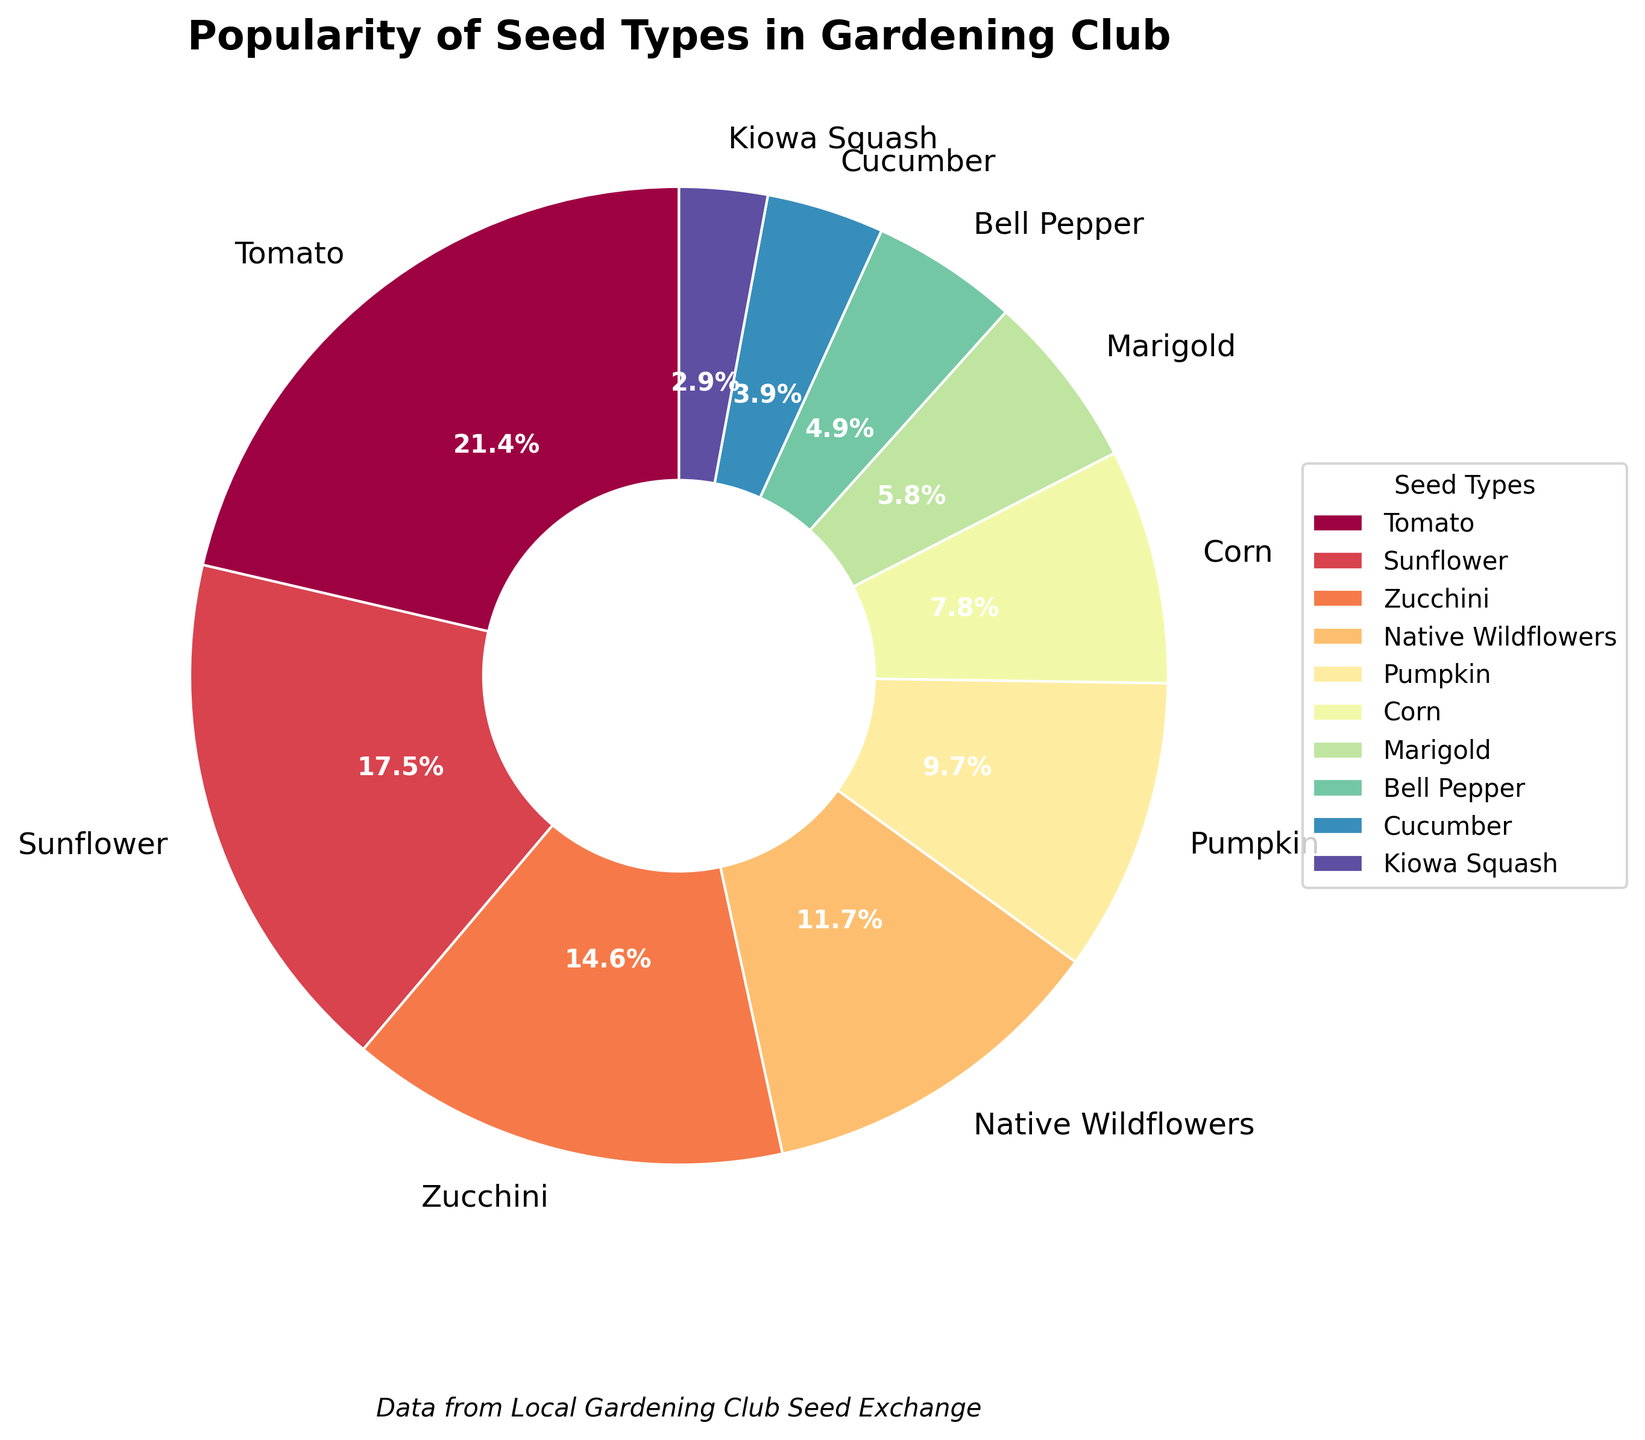Which seed type has the highest percentage in the pie chart? Examine the slices of the pie chart and look for the seed type with the largest section and the highest percentage label. This is the Tomato slice with 22%.
Answer: Tomato Which seed type has the smallest percentage? Identify the slice with the smallest section on the pie chart, labeled with the lowest percentage. This is the Kiowa Squash slice with 3%.
Answer: Kiowa Squash What is the combined percentage of Zucchini and Pumpkin? Find the Zucchini and Pumpkin slices. Their percentages are 15% and 10%, respectively. Add these together: 15% + 10% = 25%.
Answer: 25% Is the percentage of Sunflower seeds greater than that of Corn seeds? Compare the percentages labeled on the Sunflower and Corn slices. Sunflower has 18%, and Corn has 8%, so Sunflower is greater.
Answer: Yes Which has a higher percentage, Bell Pepper or Cucumber seeds? Compare the percentages for Bell Pepper and Cucumber. Bell Pepper has 5%, and Cucumber has 4%, so Bell Pepper is higher.
Answer: Bell Pepper What is the total percentage of seed types that are below 10%? Identify all the seed types below 10% from the chart: Corn (8%), Marigold (6%), Bell Pepper (5%), Cucumber (4%), and Kiowa Squash (3%). Sum these values: 8% + 6% + 5% + 4% + 3% = 26%.
Answer: 26% Are Native Wildflowers seeds more popular than Pumpkin seeds? Look for the percentages of Native Wildflowers (12%) and Pumpkin seeds (10%). Native Wildflowers have a higher percentage, hence more popular.
Answer: Yes Which seed types have percentages in the double digits besides Tomato? Examine the chart for seed types with percentages in the range of 10% to 99%. These are Sunflower (18%), Zucchini (15%), Native Wildflowers (12%), and Pumpkin (10%).
Answer: Sunflower, Zucchini, Native Wildflowers, Pumpkin How much more popular are Tomato seeds compared to Bell Pepper seeds? Subtract the percentage of Bell Pepper (5%) from Tomato seeds (22%): 22% - 5% = 17%.
Answer: 17% If you combine the percentages of the least and most popular seed types, what do you get? Identify the least popular seed, Kiowa Squash (3%), and the most popular seed, Tomato (22%). Add these percentages together: 22% + 3% = 25%.
Answer: 25% 